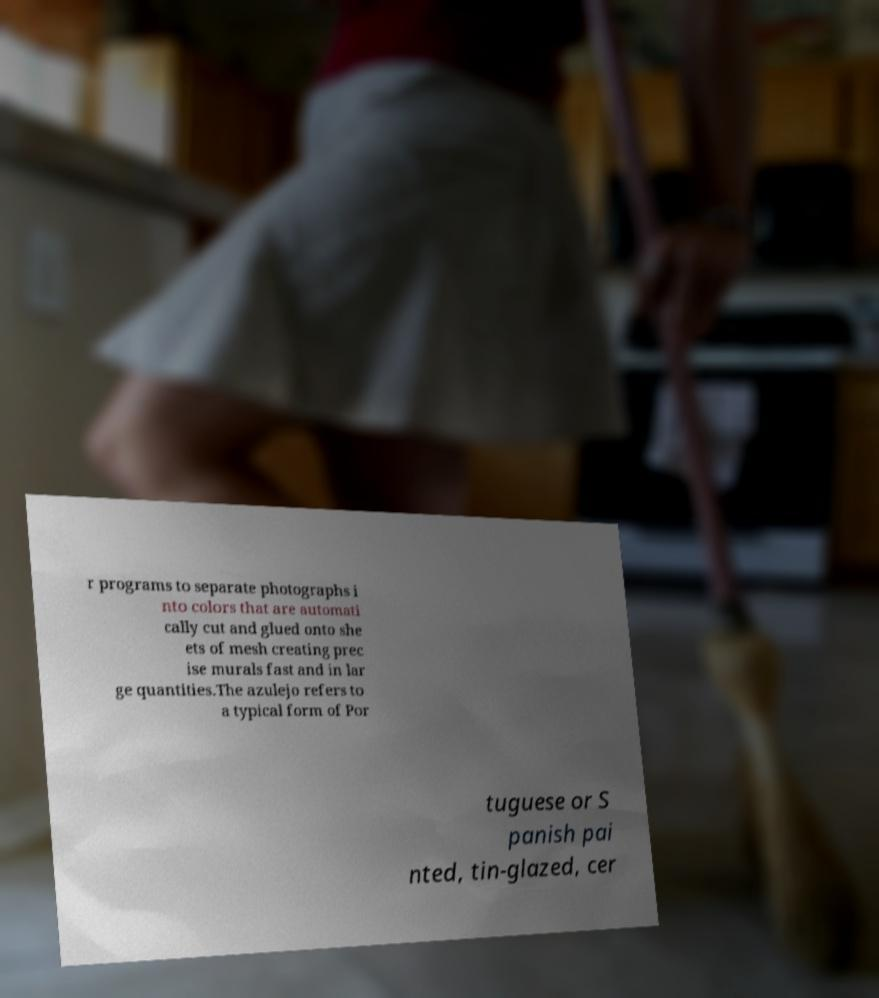Please identify and transcribe the text found in this image. r programs to separate photographs i nto colors that are automati cally cut and glued onto she ets of mesh creating prec ise murals fast and in lar ge quantities.The azulejo refers to a typical form of Por tuguese or S panish pai nted, tin-glazed, cer 